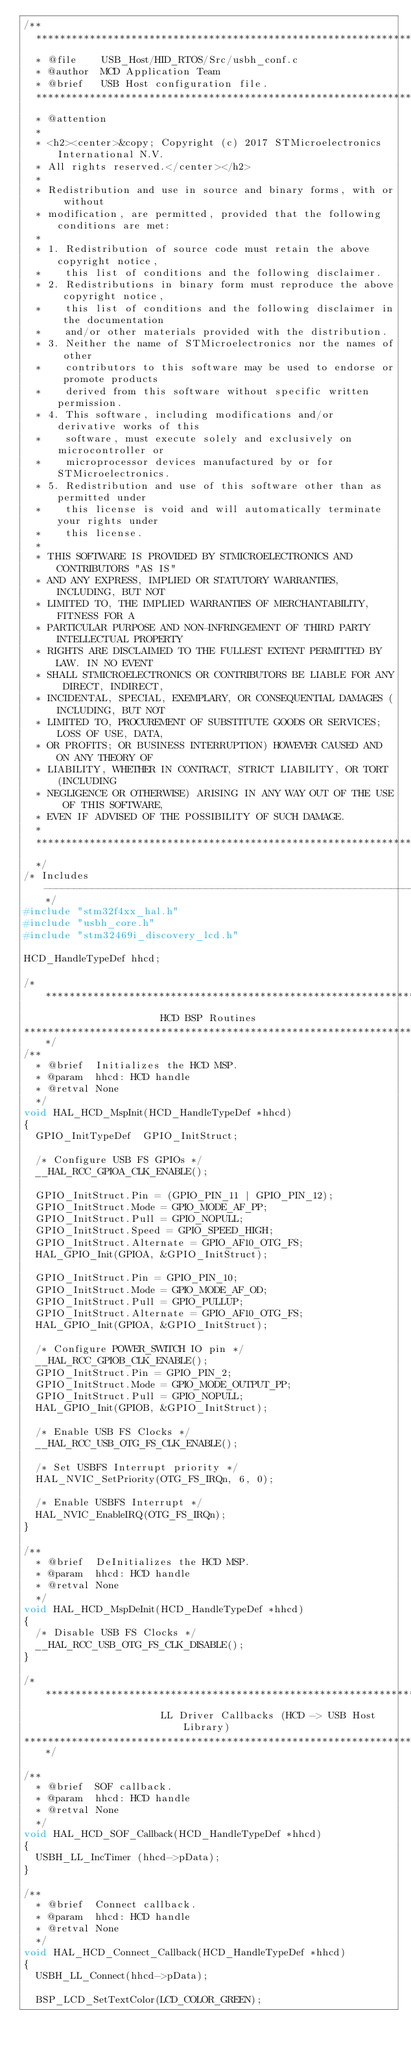Convert code to text. <code><loc_0><loc_0><loc_500><loc_500><_C_>/**
  ******************************************************************************
  * @file    USB_Host/HID_RTOS/Src/usbh_conf.c
  * @author  MCD Application Team
  * @brief   USB Host configuration file.
  ******************************************************************************
  * @attention
  *
  * <h2><center>&copy; Copyright (c) 2017 STMicroelectronics International N.V. 
  * All rights reserved.</center></h2>
  *
  * Redistribution and use in source and binary forms, with or without 
  * modification, are permitted, provided that the following conditions are met:
  *
  * 1. Redistribution of source code must retain the above copyright notice, 
  *    this list of conditions and the following disclaimer.
  * 2. Redistributions in binary form must reproduce the above copyright notice,
  *    this list of conditions and the following disclaimer in the documentation
  *    and/or other materials provided with the distribution.
  * 3. Neither the name of STMicroelectronics nor the names of other 
  *    contributors to this software may be used to endorse or promote products 
  *    derived from this software without specific written permission.
  * 4. This software, including modifications and/or derivative works of this 
  *    software, must execute solely and exclusively on microcontroller or
  *    microprocessor devices manufactured by or for STMicroelectronics.
  * 5. Redistribution and use of this software other than as permitted under 
  *    this license is void and will automatically terminate your rights under 
  *    this license. 
  *
  * THIS SOFTWARE IS PROVIDED BY STMICROELECTRONICS AND CONTRIBUTORS "AS IS" 
  * AND ANY EXPRESS, IMPLIED OR STATUTORY WARRANTIES, INCLUDING, BUT NOT 
  * LIMITED TO, THE IMPLIED WARRANTIES OF MERCHANTABILITY, FITNESS FOR A 
  * PARTICULAR PURPOSE AND NON-INFRINGEMENT OF THIRD PARTY INTELLECTUAL PROPERTY
  * RIGHTS ARE DISCLAIMED TO THE FULLEST EXTENT PERMITTED BY LAW. IN NO EVENT 
  * SHALL STMICROELECTRONICS OR CONTRIBUTORS BE LIABLE FOR ANY DIRECT, INDIRECT,
  * INCIDENTAL, SPECIAL, EXEMPLARY, OR CONSEQUENTIAL DAMAGES (INCLUDING, BUT NOT
  * LIMITED TO, PROCUREMENT OF SUBSTITUTE GOODS OR SERVICES; LOSS OF USE, DATA, 
  * OR PROFITS; OR BUSINESS INTERRUPTION) HOWEVER CAUSED AND ON ANY THEORY OF 
  * LIABILITY, WHETHER IN CONTRACT, STRICT LIABILITY, OR TORT (INCLUDING 
  * NEGLIGENCE OR OTHERWISE) ARISING IN ANY WAY OUT OF THE USE OF THIS SOFTWARE,
  * EVEN IF ADVISED OF THE POSSIBILITY OF SUCH DAMAGE.
  *
  ******************************************************************************
  */
/* Includes ------------------------------------------------------------------*/
#include "stm32f4xx_hal.h"
#include "usbh_core.h"
#include "stm32469i_discovery_lcd.h"

HCD_HandleTypeDef hhcd;

/*******************************************************************************
                       HCD BSP Routines
*******************************************************************************/
/**
  * @brief  Initializes the HCD MSP.
  * @param  hhcd: HCD handle
  * @retval None
  */
void HAL_HCD_MspInit(HCD_HandleTypeDef *hhcd)
{
  GPIO_InitTypeDef  GPIO_InitStruct;
  
  /* Configure USB FS GPIOs */
  __HAL_RCC_GPIOA_CLK_ENABLE();
  
  GPIO_InitStruct.Pin = (GPIO_PIN_11 | GPIO_PIN_12);
  GPIO_InitStruct.Mode = GPIO_MODE_AF_PP;
  GPIO_InitStruct.Pull = GPIO_NOPULL;
  GPIO_InitStruct.Speed = GPIO_SPEED_HIGH;
  GPIO_InitStruct.Alternate = GPIO_AF10_OTG_FS;
  HAL_GPIO_Init(GPIOA, &GPIO_InitStruct); 
  
  GPIO_InitStruct.Pin = GPIO_PIN_10;
  GPIO_InitStruct.Mode = GPIO_MODE_AF_OD;
  GPIO_InitStruct.Pull = GPIO_PULLUP;
  GPIO_InitStruct.Alternate = GPIO_AF10_OTG_FS;
  HAL_GPIO_Init(GPIOA, &GPIO_InitStruct); 
  
  /* Configure POWER_SWITCH IO pin */
  __HAL_RCC_GPIOB_CLK_ENABLE();
  GPIO_InitStruct.Pin = GPIO_PIN_2;
  GPIO_InitStruct.Mode = GPIO_MODE_OUTPUT_PP;
  GPIO_InitStruct.Pull = GPIO_NOPULL;
  HAL_GPIO_Init(GPIOB, &GPIO_InitStruct); 
  
  /* Enable USB FS Clocks */ 
  __HAL_RCC_USB_OTG_FS_CLK_ENABLE();
  
  /* Set USBFS Interrupt priority */
  HAL_NVIC_SetPriority(OTG_FS_IRQn, 6, 0);
  
  /* Enable USBFS Interrupt */
  HAL_NVIC_EnableIRQ(OTG_FS_IRQn);
}

/**
  * @brief  DeInitializes the HCD MSP.
  * @param  hhcd: HCD handle
  * @retval None
  */
void HAL_HCD_MspDeInit(HCD_HandleTypeDef *hhcd)
{
  /* Disable USB FS Clocks */ 
  __HAL_RCC_USB_OTG_FS_CLK_DISABLE();
}

/*******************************************************************************
                       LL Driver Callbacks (HCD -> USB Host Library)
*******************************************************************************/

/**
  * @brief  SOF callback.
  * @param  hhcd: HCD handle
  * @retval None
  */
void HAL_HCD_SOF_Callback(HCD_HandleTypeDef *hhcd)
{
  USBH_LL_IncTimer (hhcd->pData);
}

/**
  * @brief  Connect callback.
  * @param  hhcd: HCD handle
  * @retval None
  */
void HAL_HCD_Connect_Callback(HCD_HandleTypeDef *hhcd)
{
  USBH_LL_Connect(hhcd->pData);
  
  BSP_LCD_SetTextColor(LCD_COLOR_GREEN);</code> 